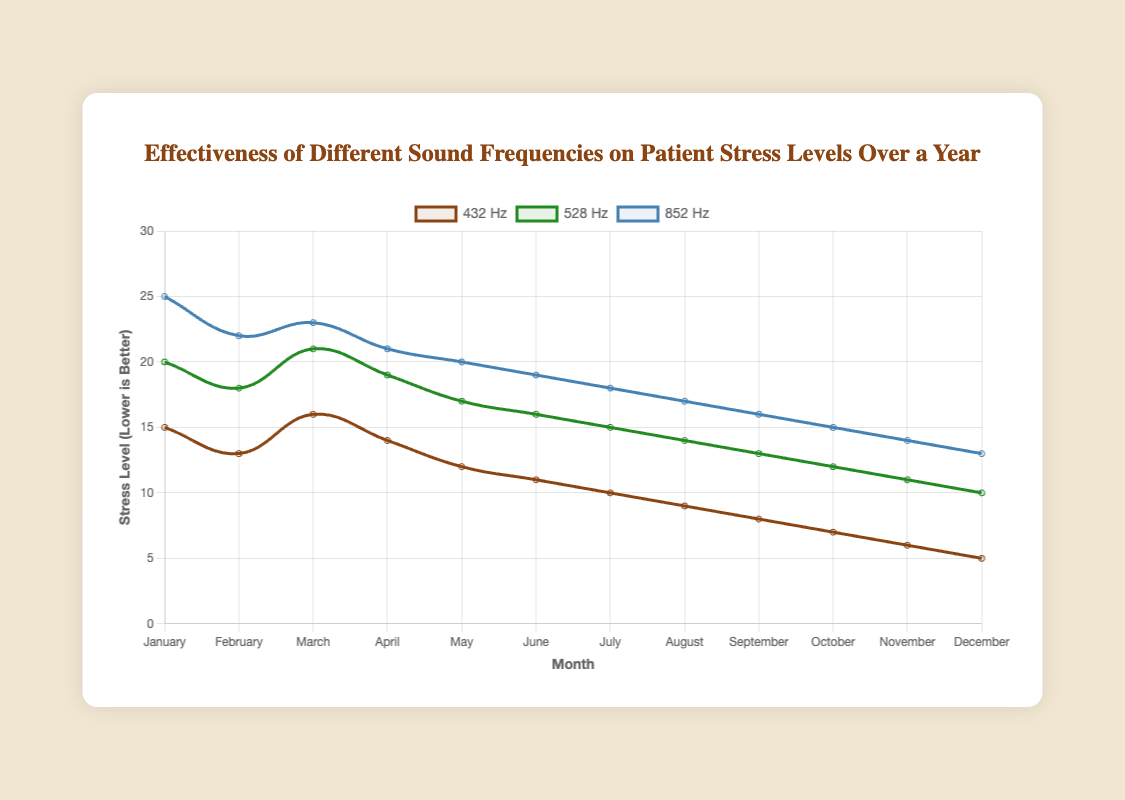Which frequency has the lowest stress level in December? To find the frequency with the lowest stress level in December, look at the December data points. They are 5 for 432 Hz, 10 for 528 Hz, and 13 for 852 Hz. The lowest value is 5 for 432 Hz.
Answer: 432 Hz What is the difference in stress levels between 528 Hz and 852 Hz in May? The stress level for 528 Hz in May is 17, and the stress level for 852 Hz in May is 20. The difference is 20 - 17 = 3.
Answer: 3 During which month is the stress level for 432 Hz equal to the stress level for 528 Hz? Compare the stress levels for 432 Hz and 528 Hz across all months. They are never equal in this dataset.
Answer: Never In which month is the decrease in stress levels for 528 Hz the largest? Calculate the decrease in stress levels month-over-month for 528 Hz. The decreases are: January-February: 20 - 18 = 2, February-March: 18 - 21 = -3 (increase), March-April: 21 - 19 = 2, April-May: 19 - 17 = 2, May-June: 17 - 16 = 1, June-July: 16 - 15 = 1, July-August: 15 - 14 = 1, August-September: 14 - 13 = 1, September-October: 13 - 12 = 1, October-November: 12 - 11 = 1, November-December: 11 - 10 = 1. The largest decrease is from February to March, but it’s an increase. No large decrease greater than 2.
Answer: None greater than 2 What is the average stress level for 432 Hz over the year? The data points for 432 Hz are: 15, 13, 16, 14, 12, 11, 10, 9, 8, 7, 6, 5. Sum these values: 15 + 13 + 16 + 14 + 12 + 11 + 10 + 9 + 8 + 7 + 6 + 5 = 126. Divide by 12 months: 126 / 12 = 10.5.
Answer: 10.5 Compare the trend lines for 432 Hz and 852 Hz, which one shows a steeper decline in stress levels over the year? To determine which one has a steeper decline, observe the start and end values for each frequency over the year. For 432 Hz, the stress levels change from 15 to 5, a decrease of 10 units. For 852 Hz, the stress levels change from 25 to 13, a decrease of 12 units. Thus, 852 Hz shows a steeper decline.
Answer: 852 Hz What is the total decrease in stress levels for 852 Hz from January to December? The stress level for 852 Hz in January is 25, and in December it is 13. The total decrease is 25 - 13 = 12.
Answer: 12 Which month shows a plateau in stress levels for 528 Hz, indicating no change from the previous month? Compare month-over-month values for 528 Hz: January-February: 20-18, February-March: 18-21, March-April: 21-19, April-May: 19-17, May-June: 17-16, June-July: 16-15, July-August: 15-14, August-September: 14-13, September-October: 13-12, October-November: 12-11, November-December: 11-10. There are no months showing a plateau (no change).
Answer: None Identify the month which had the highest stress level for 852 Hz. The highest value for 852 Hz is in January, which is 25.
Answer: January 